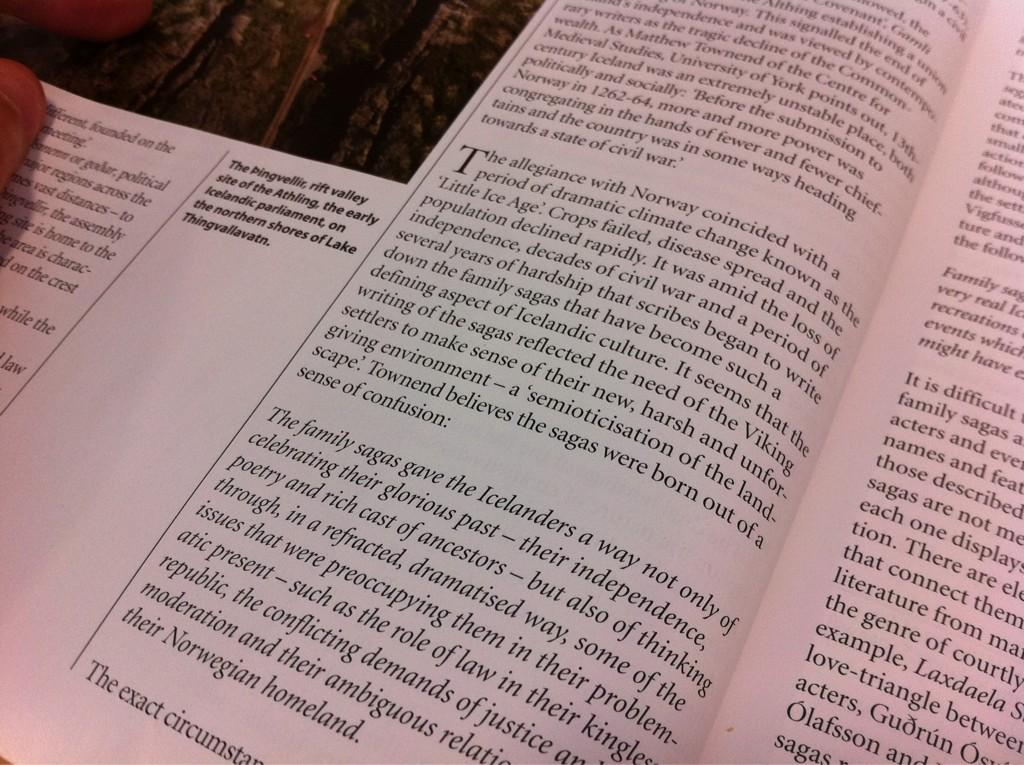<image>
Provide a brief description of the given image. an open book that says 'the allegiance with norway coincided...' 